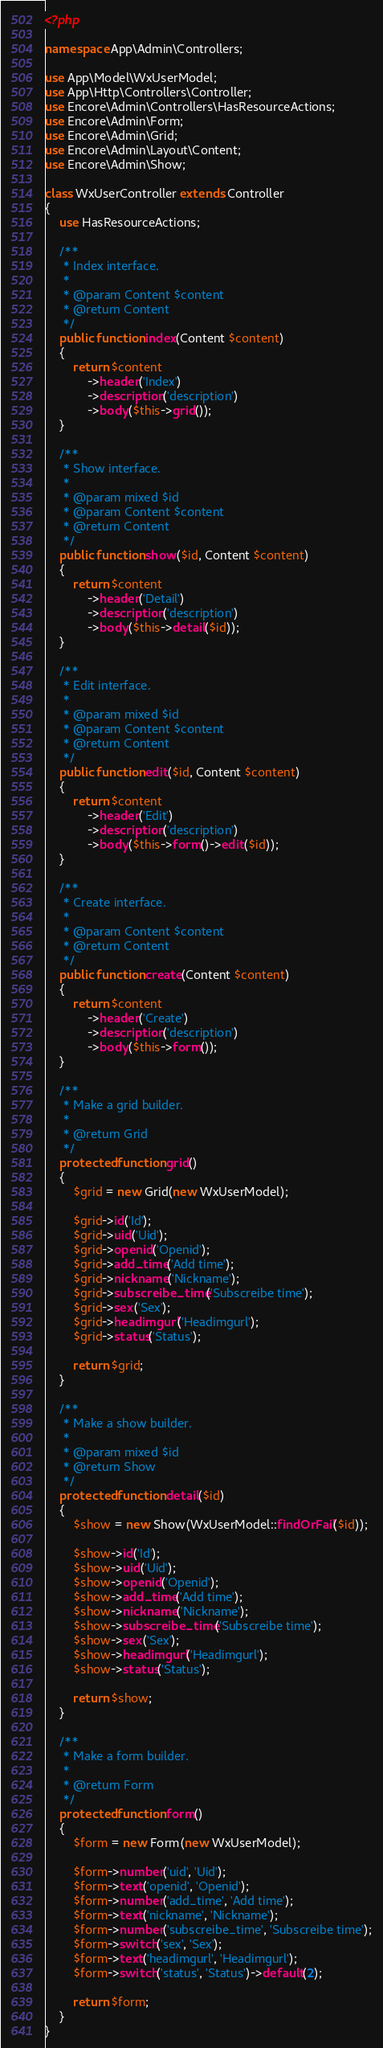<code> <loc_0><loc_0><loc_500><loc_500><_PHP_><?php

namespace App\Admin\Controllers;

use App\Model\WxUserModel;
use App\Http\Controllers\Controller;
use Encore\Admin\Controllers\HasResourceActions;
use Encore\Admin\Form;
use Encore\Admin\Grid;
use Encore\Admin\Layout\Content;
use Encore\Admin\Show;

class WxUserController extends Controller
{
    use HasResourceActions;

    /**
     * Index interface.
     *
     * @param Content $content
     * @return Content
     */
    public function index(Content $content)
    {
        return $content
            ->header('Index')
            ->description('description')
            ->body($this->grid());
    }

    /**
     * Show interface.
     *
     * @param mixed $id
     * @param Content $content
     * @return Content
     */
    public function show($id, Content $content)
    {
        return $content
            ->header('Detail')
            ->description('description')
            ->body($this->detail($id));
    }

    /**
     * Edit interface.
     *
     * @param mixed $id
     * @param Content $content
     * @return Content
     */
    public function edit($id, Content $content)
    {
        return $content
            ->header('Edit')
            ->description('description')
            ->body($this->form()->edit($id));
    }

    /**
     * Create interface.
     *
     * @param Content $content
     * @return Content
     */
    public function create(Content $content)
    {
        return $content
            ->header('Create')
            ->description('description')
            ->body($this->form());
    }

    /**
     * Make a grid builder.
     *
     * @return Grid
     */
    protected function grid()
    {
        $grid = new Grid(new WxUserModel);

        $grid->id('Id');
        $grid->uid('Uid');
        $grid->openid('Openid');
        $grid->add_time('Add time');
        $grid->nickname('Nickname');
        $grid->subscreibe_time('Subscreibe time');
        $grid->sex('Sex');
        $grid->headimgurl('Headimgurl');
        $grid->status('Status');

        return $grid;
    }

    /**
     * Make a show builder.
     *
     * @param mixed $id
     * @return Show
     */
    protected function detail($id)
    {
        $show = new Show(WxUserModel::findOrFail($id));

        $show->id('Id');
        $show->uid('Uid');
        $show->openid('Openid');
        $show->add_time('Add time');
        $show->nickname('Nickname');
        $show->subscreibe_time('Subscreibe time');
        $show->sex('Sex');
        $show->headimgurl('Headimgurl');
        $show->status('Status');

        return $show;
    }

    /**
     * Make a form builder.
     *
     * @return Form
     */
    protected function form()
    {
        $form = new Form(new WxUserModel);

        $form->number('uid', 'Uid');
        $form->text('openid', 'Openid');
        $form->number('add_time', 'Add time');
        $form->text('nickname', 'Nickname');
        $form->number('subscreibe_time', 'Subscreibe time');
        $form->switch('sex', 'Sex');
        $form->text('headimgurl', 'Headimgurl');
        $form->switch('status', 'Status')->default(2);

        return $form;
    }
}
</code> 